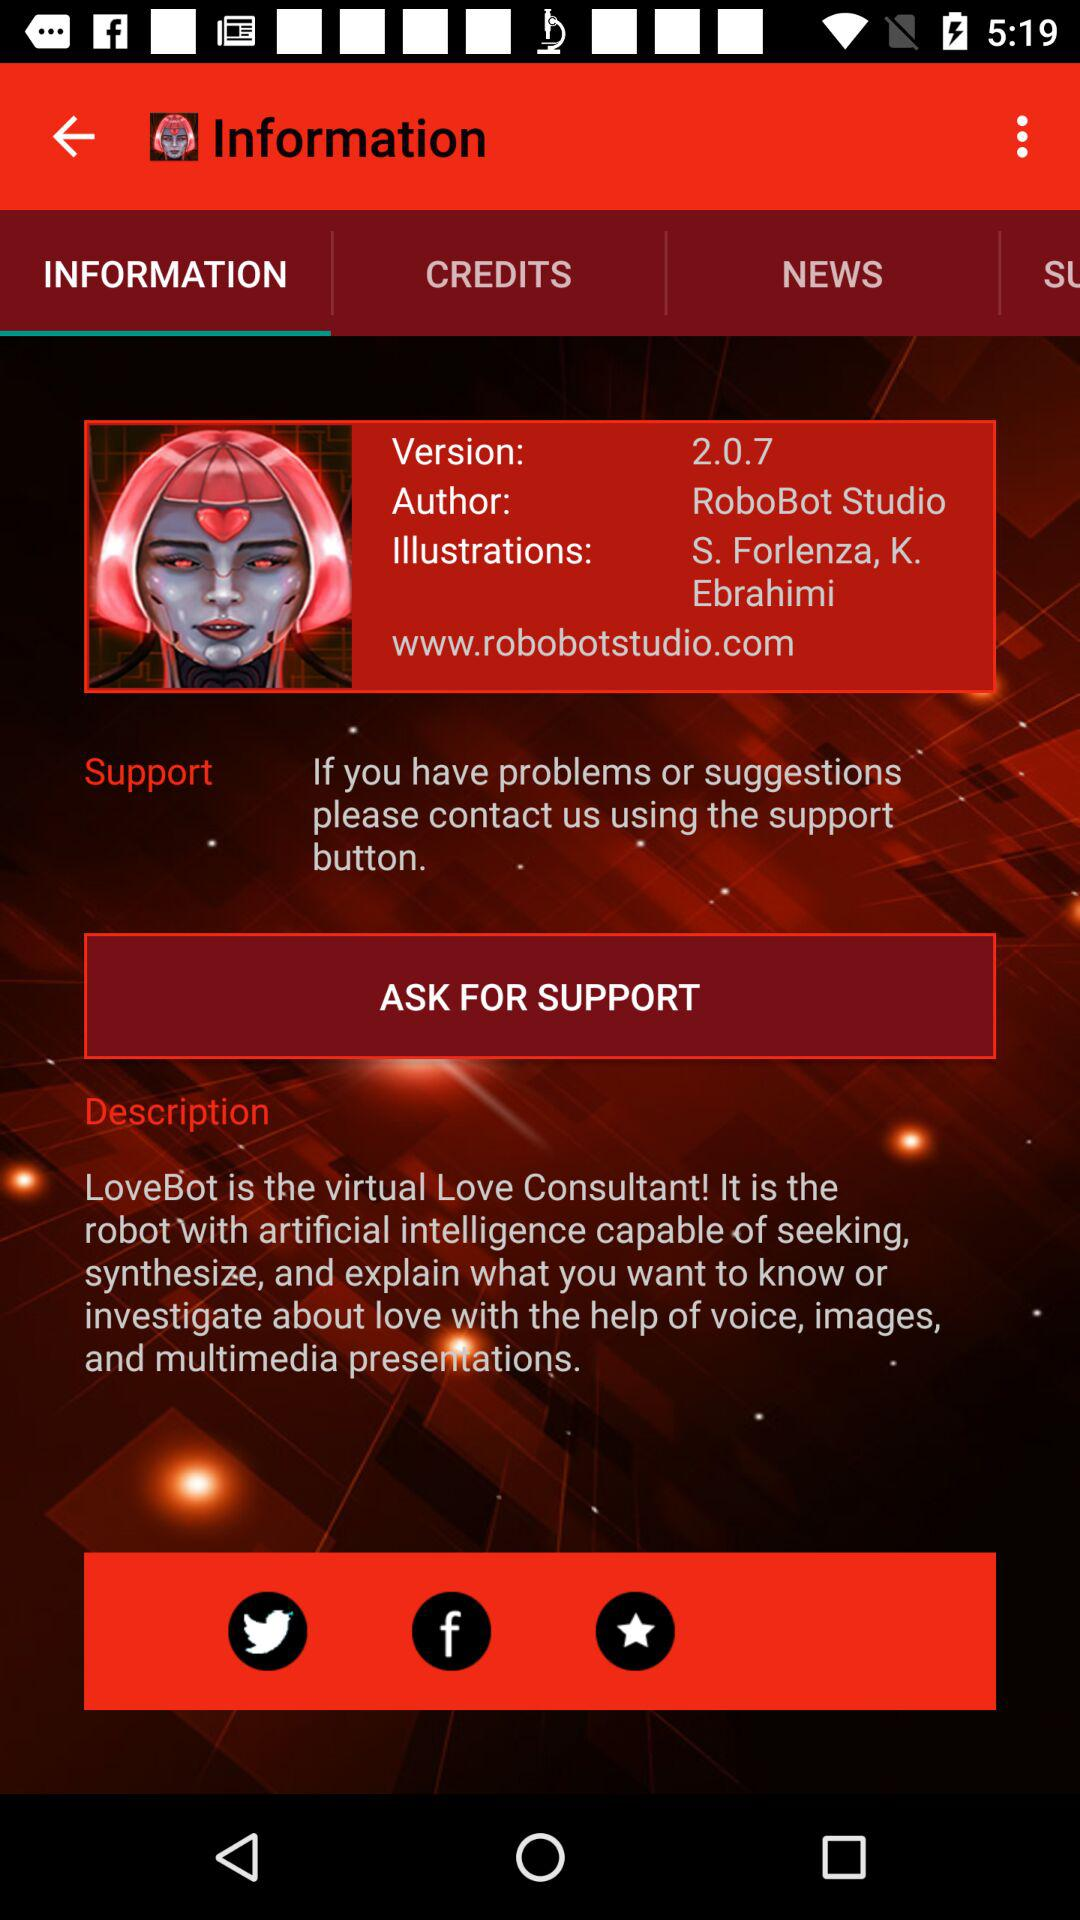What version is this? The version is 2.0.7. 